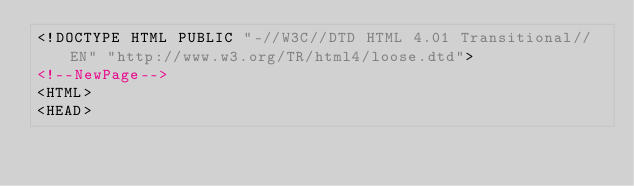Convert code to text. <code><loc_0><loc_0><loc_500><loc_500><_HTML_><!DOCTYPE HTML PUBLIC "-//W3C//DTD HTML 4.01 Transitional//EN" "http://www.w3.org/TR/html4/loose.dtd">
<!--NewPage-->
<HTML>
<HEAD></code> 